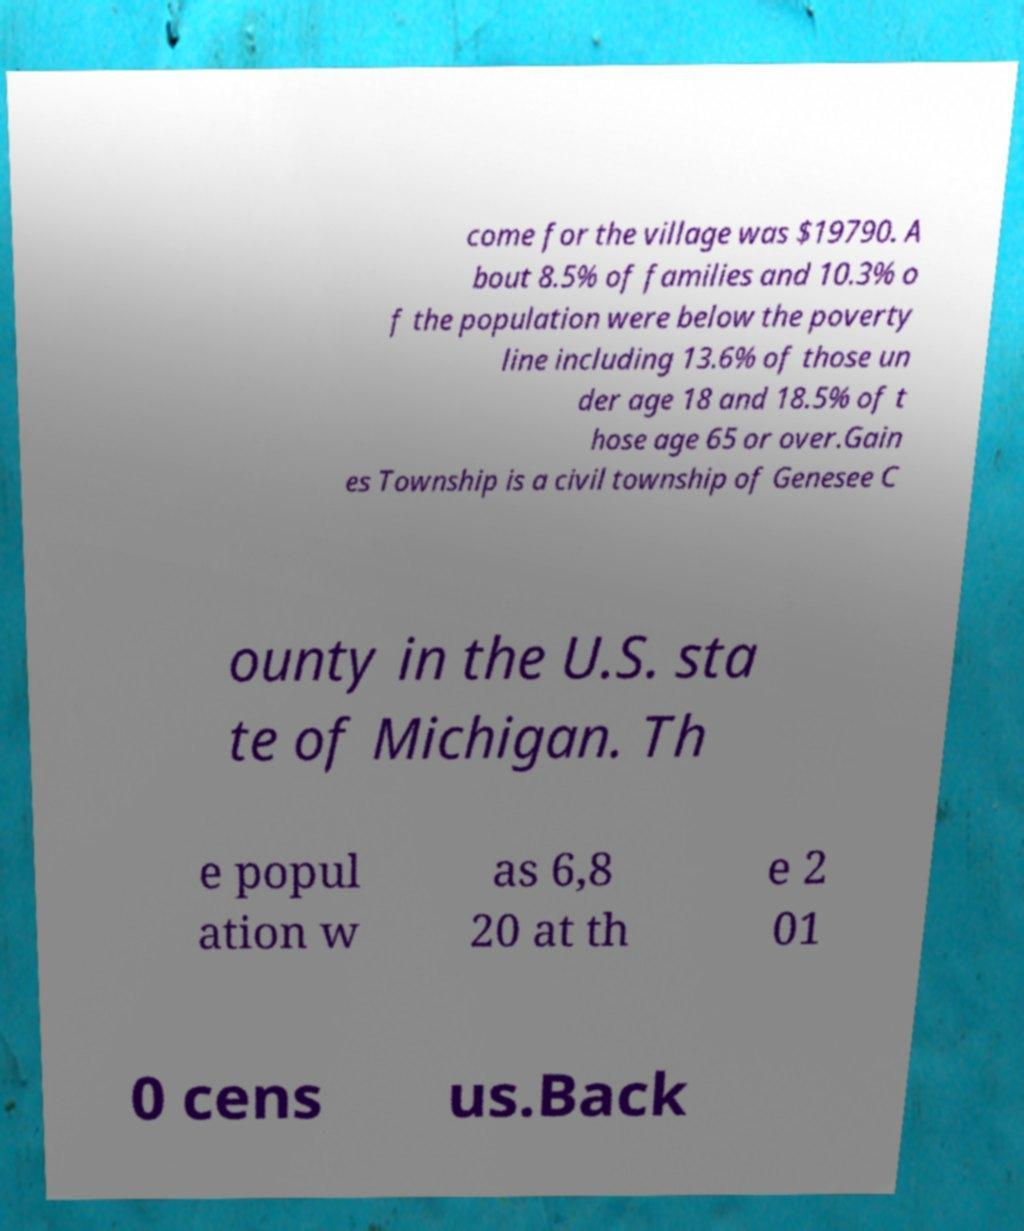Could you assist in decoding the text presented in this image and type it out clearly? come for the village was $19790. A bout 8.5% of families and 10.3% o f the population were below the poverty line including 13.6% of those un der age 18 and 18.5% of t hose age 65 or over.Gain es Township is a civil township of Genesee C ounty in the U.S. sta te of Michigan. Th e popul ation w as 6,8 20 at th e 2 01 0 cens us.Back 